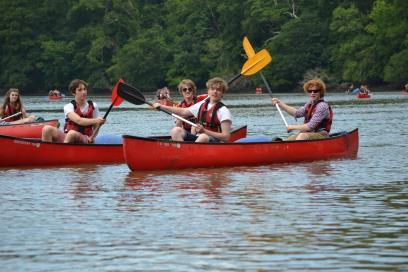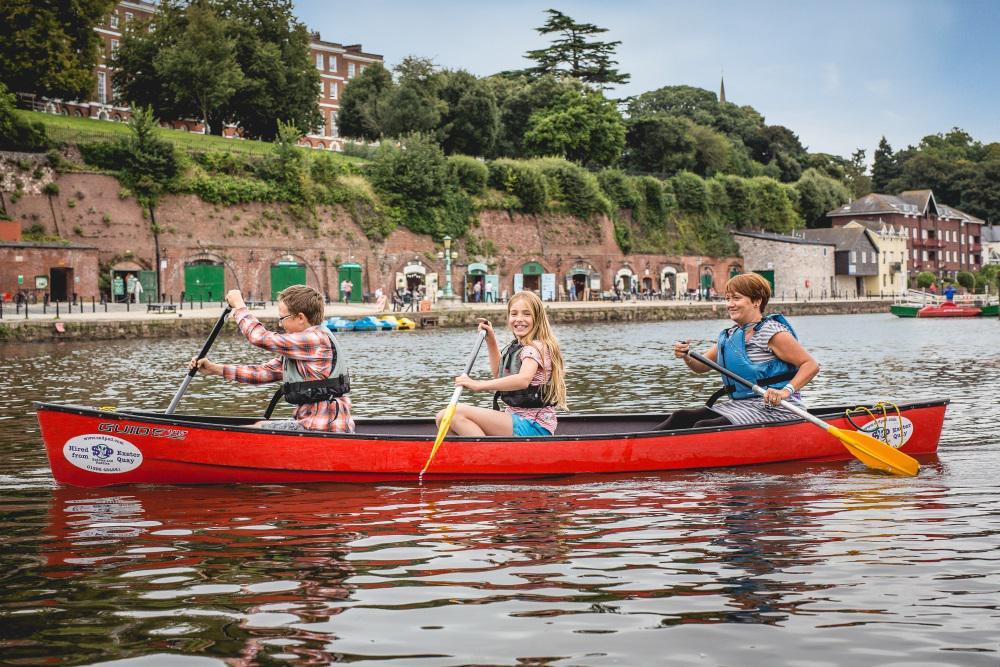The first image is the image on the left, the second image is the image on the right. Evaluate the accuracy of this statement regarding the images: "In each picture on the right, there are 3 people in a red canoe.". Is it true? Answer yes or no. Yes. 